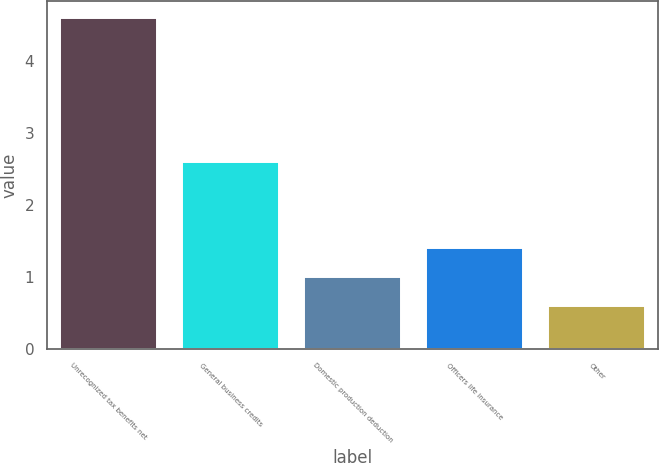Convert chart to OTSL. <chart><loc_0><loc_0><loc_500><loc_500><bar_chart><fcel>Unrecognized tax benefits net<fcel>General business credits<fcel>Domestic production deduction<fcel>Officers life insurance<fcel>Other<nl><fcel>4.6<fcel>2.6<fcel>1<fcel>1.4<fcel>0.6<nl></chart> 